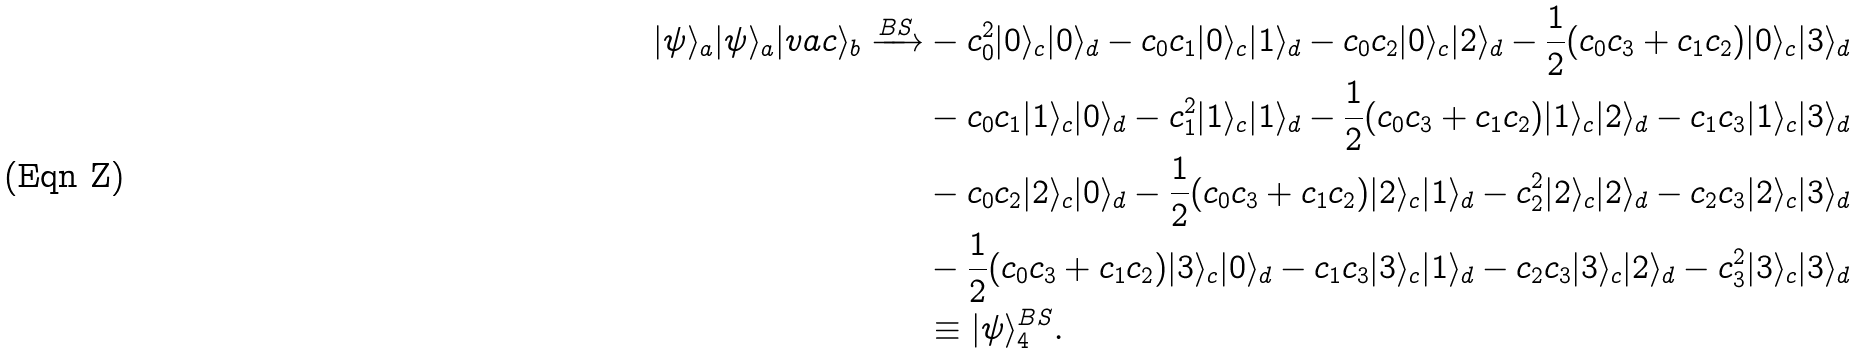<formula> <loc_0><loc_0><loc_500><loc_500>| \psi \rangle _ { a } | \psi \rangle _ { a } | v a c \rangle _ { b } \xrightarrow { B S } & - c _ { 0 } ^ { 2 } | 0 \rangle _ { c } | 0 \rangle _ { d } - c _ { 0 } c _ { 1 } | 0 \rangle _ { c } | 1 \rangle _ { d } - c _ { 0 } c _ { 2 } | 0 \rangle _ { c } | 2 \rangle _ { d } - \frac { 1 } { 2 } ( c _ { 0 } c _ { 3 } + c _ { 1 } c _ { 2 } ) | 0 \rangle _ { c } | 3 \rangle _ { d } \\ & - c _ { 0 } c _ { 1 } | 1 \rangle _ { c } | 0 \rangle _ { d } - c _ { 1 } ^ { 2 } | 1 \rangle _ { c } | 1 \rangle _ { d } - \frac { 1 } { 2 } ( c _ { 0 } c _ { 3 } + c _ { 1 } c _ { 2 } ) | 1 \rangle _ { c } | 2 \rangle _ { d } - c _ { 1 } c _ { 3 } | 1 \rangle _ { c } | 3 \rangle _ { d } \\ & - c _ { 0 } c _ { 2 } | 2 \rangle _ { c } | 0 \rangle _ { d } - \frac { 1 } { 2 } ( c _ { 0 } c _ { 3 } + c _ { 1 } c _ { 2 } ) | 2 \rangle _ { c } | 1 \rangle _ { d } - c _ { 2 } ^ { 2 } | 2 \rangle _ { c } | 2 \rangle _ { d } - c _ { 2 } c _ { 3 } | 2 \rangle _ { c } | 3 \rangle _ { d } \\ & - \frac { 1 } { 2 } ( c _ { 0 } c _ { 3 } + c _ { 1 } c _ { 2 } ) | 3 \rangle _ { c } | 0 \rangle _ { d } - c _ { 1 } c _ { 3 } | 3 \rangle _ { c } | 1 \rangle _ { d } - c _ { 2 } c _ { 3 } | 3 \rangle _ { c } | 2 \rangle _ { d } - c _ { 3 } ^ { 2 } | 3 \rangle _ { c } | 3 \rangle _ { d } \\ & \equiv | \psi \rangle _ { 4 } ^ { B S } .</formula> 